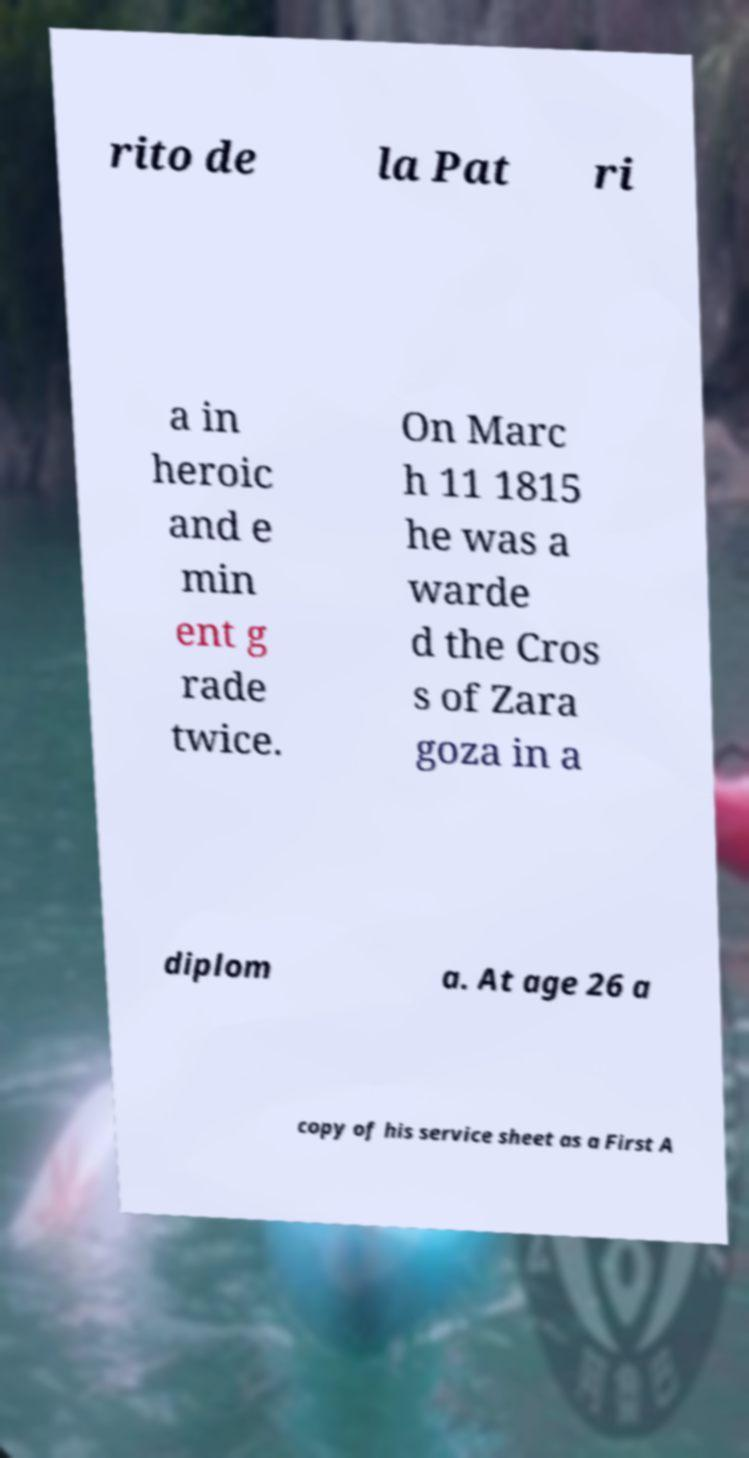Could you extract and type out the text from this image? rito de la Pat ri a in heroic and e min ent g rade twice. On Marc h 11 1815 he was a warde d the Cros s of Zara goza in a diplom a. At age 26 a copy of his service sheet as a First A 